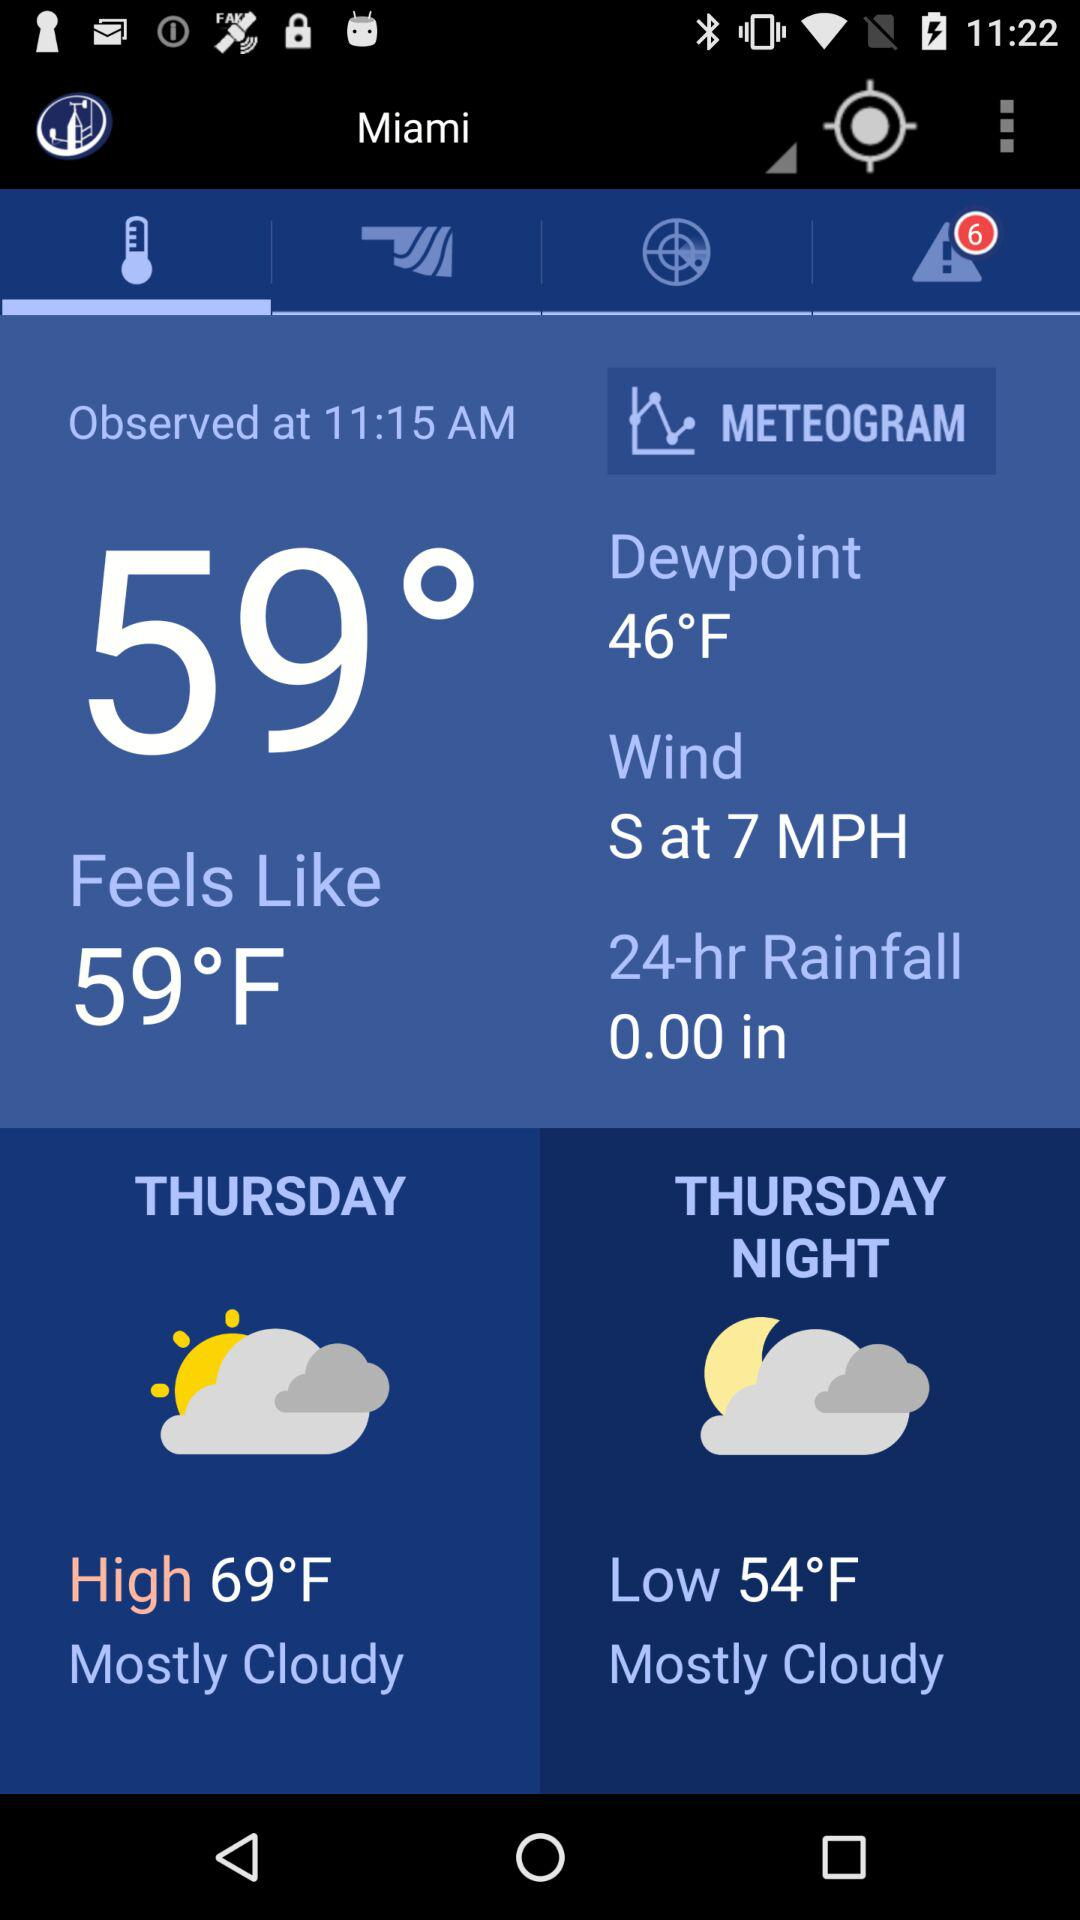How many alert notifications are there? There are 6 alert notifications. 